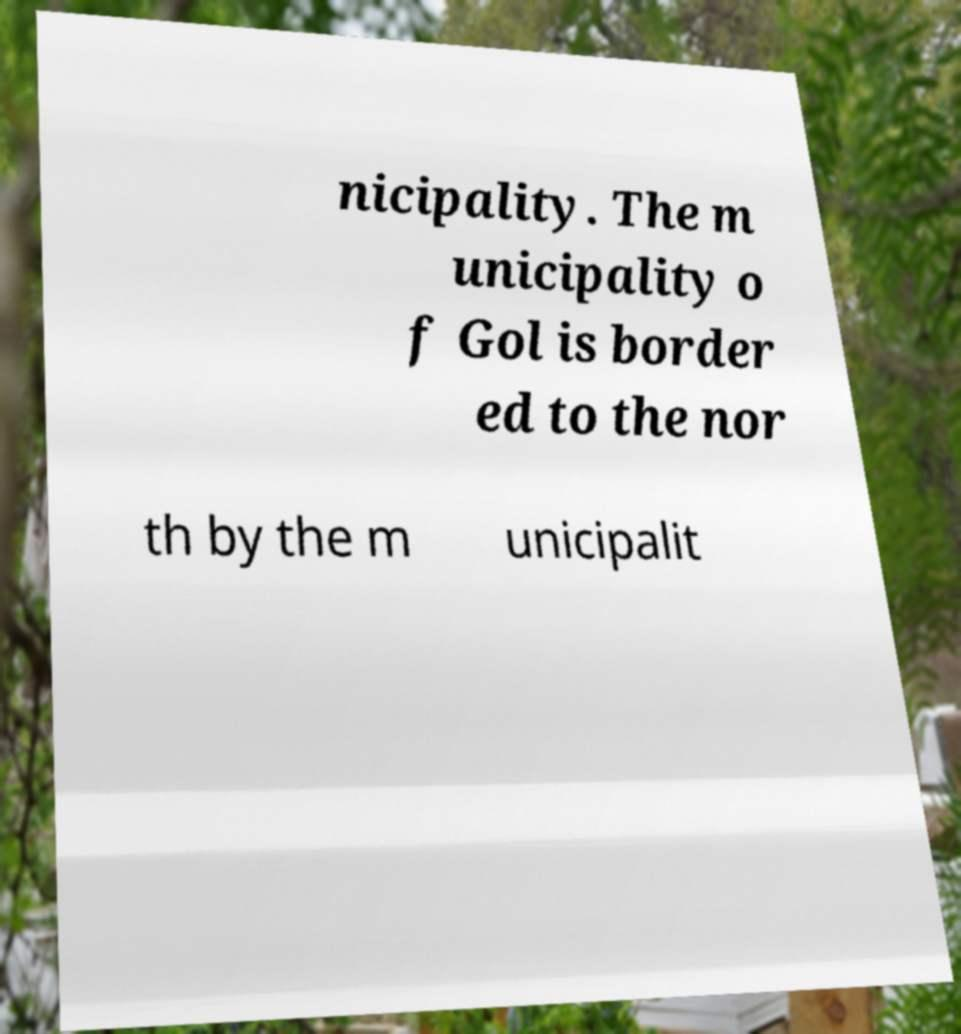Please identify and transcribe the text found in this image. nicipality. The m unicipality o f Gol is border ed to the nor th by the m unicipalit 